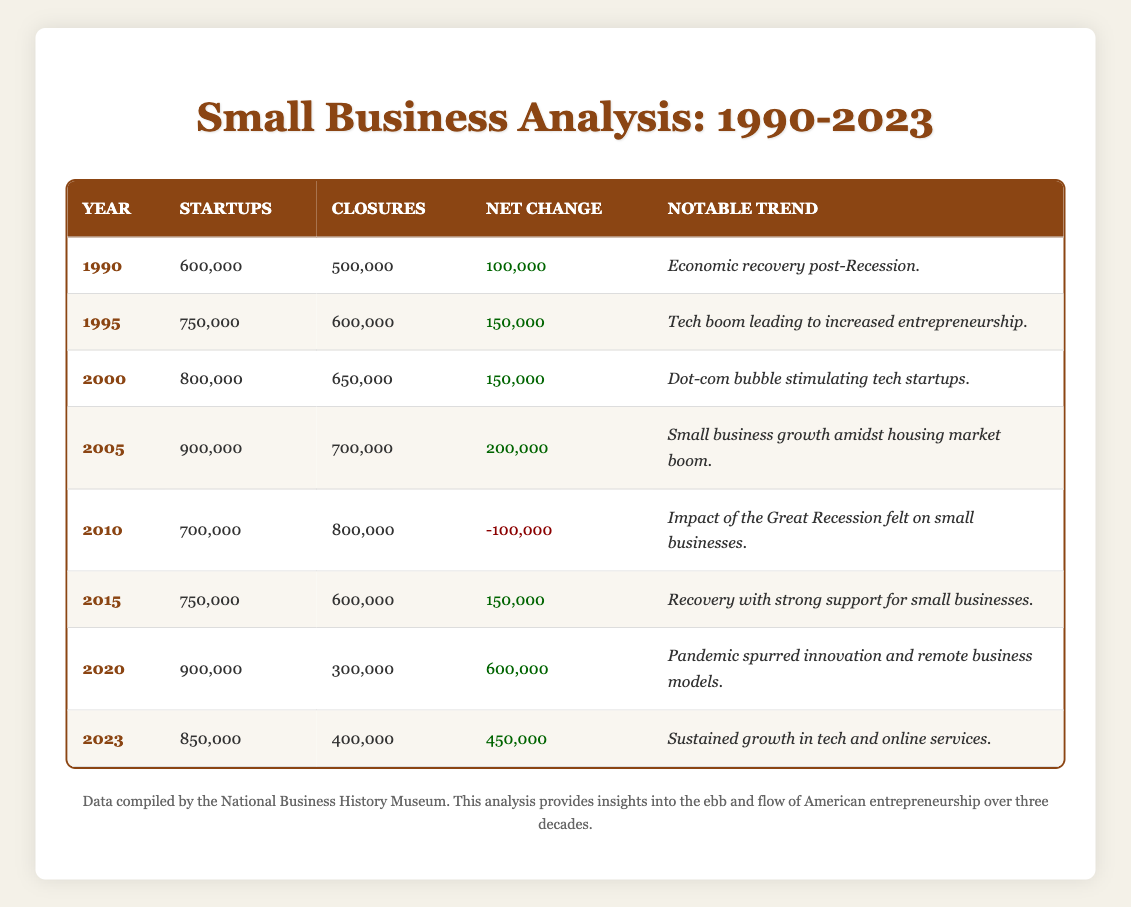What was the net change in small businesses in 1990? The net change for 1990 is directly listed in the table under the "Net Change" column, which shows 100,000.
Answer: 100000 In which year did small business closures first exceed startups? By looking at the "Startups" and "Closures" columns, we can see that in 2010, closures (800,000) exceeded startups (700,000), indicating that it was the first year this occurred.
Answer: 2010 What is the total number of startups from 1990 to 2023? To find the total, add the number of startups for each year: 600000 + 750000 + 800000 + 900000 + 700000 + 750000 + 900000 + 850000 = 4850000.
Answer: 4850000 Is it true that the number of startups increased every year from 1990 to 2005? Inspecting the "Startups" column from 1990 to 2005 reveals that the startups increased from 600,000 in 1990 to 900,000 in 2005, confirming the trend of yearly growth.
Answer: Yes What was the average number of closures from 2010 to 2023? The closures for the years 2010, 2015, 2020, and 2023 are 800000, 600000, 300000, and 400000 respectively. To find the average, sum these values (800000 + 600000 + 300000 + 400000 = 2100000) and divide by the number of years (4), resulting in an average of 525000.
Answer: 525000 In what year was the highest net change recorded? The highest net change can be identified by examining the "Net Change" column, where 600,000 in 2020 stands out as the maximum value.
Answer: 2020 What notable trend emerged in 2015? The table describes that the year 2015 was characterized by a recovery due to "strong support for small businesses," which is explicitly mentioned under the "Notable Trend" column.
Answer: Recovery with strong support for small businesses How many more startups occurred in 2020 compared to 2010? Startups in 2020 total 900,000 while in 2010 they totaled 700,000. The difference (900000 - 700000) indicates there were 200,000 more startups in 2020 than in 2010.
Answer: 200000 